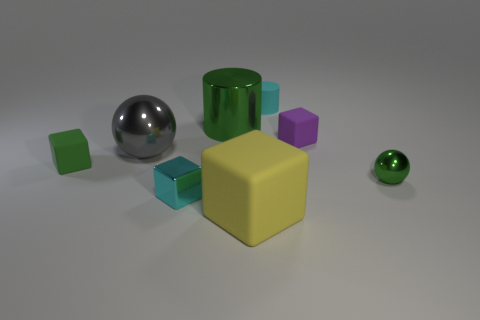Does the matte cylinder have the same size as the metal sphere to the right of the tiny cyan metal thing?
Offer a very short reply. Yes. There is a object that is behind the tiny green rubber object and left of the tiny cyan metallic thing; what is its size?
Make the answer very short. Large. Are there any small rubber things that have the same color as the tiny metal ball?
Provide a succinct answer. Yes. The rubber object in front of the cyan object that is in front of the green metal sphere is what color?
Ensure brevity in your answer.  Yellow. Is the number of small cyan rubber cylinders on the right side of the big green metal thing less than the number of rubber objects behind the metal cube?
Your answer should be very brief. Yes. Does the purple block have the same size as the green cube?
Offer a terse response. Yes. The matte object that is both in front of the purple rubber thing and behind the yellow matte cube has what shape?
Your answer should be very brief. Cube. How many large yellow blocks are the same material as the tiny sphere?
Give a very brief answer. 0. There is a large thing in front of the small green rubber thing; what number of tiny matte cubes are to the right of it?
Your response must be concise. 1. The big thing that is behind the sphere behind the tiny green block left of the gray object is what shape?
Keep it short and to the point. Cylinder. 